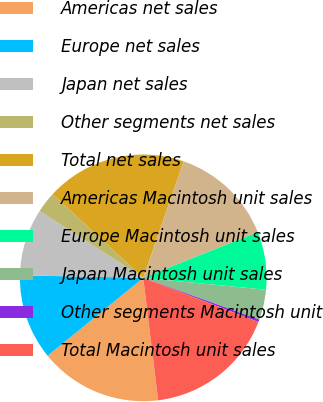Convert chart. <chart><loc_0><loc_0><loc_500><loc_500><pie_chart><fcel>Americas net sales<fcel>Europe net sales<fcel>Japan net sales<fcel>Other segments net sales<fcel>Total net sales<fcel>Americas Macintosh unit sales<fcel>Europe Macintosh unit sales<fcel>Japan Macintosh unit sales<fcel>Other segments Macintosh unit<fcel>Total Macintosh unit sales<nl><fcel>16.04%<fcel>11.21%<fcel>8.79%<fcel>2.75%<fcel>18.46%<fcel>13.63%<fcel>7.58%<fcel>3.96%<fcel>0.33%<fcel>17.25%<nl></chart> 